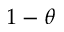Convert formula to latex. <formula><loc_0><loc_0><loc_500><loc_500>1 - \theta</formula> 